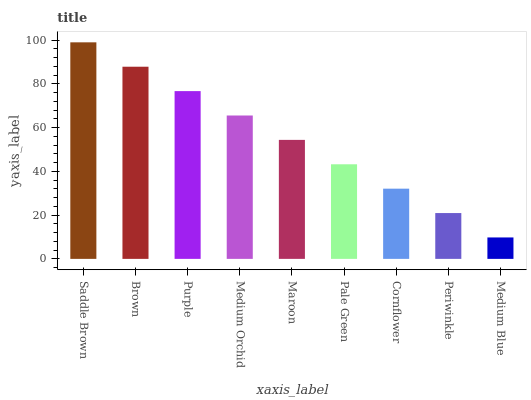Is Medium Blue the minimum?
Answer yes or no. Yes. Is Saddle Brown the maximum?
Answer yes or no. Yes. Is Brown the minimum?
Answer yes or no. No. Is Brown the maximum?
Answer yes or no. No. Is Saddle Brown greater than Brown?
Answer yes or no. Yes. Is Brown less than Saddle Brown?
Answer yes or no. Yes. Is Brown greater than Saddle Brown?
Answer yes or no. No. Is Saddle Brown less than Brown?
Answer yes or no. No. Is Maroon the high median?
Answer yes or no. Yes. Is Maroon the low median?
Answer yes or no. Yes. Is Pale Green the high median?
Answer yes or no. No. Is Brown the low median?
Answer yes or no. No. 